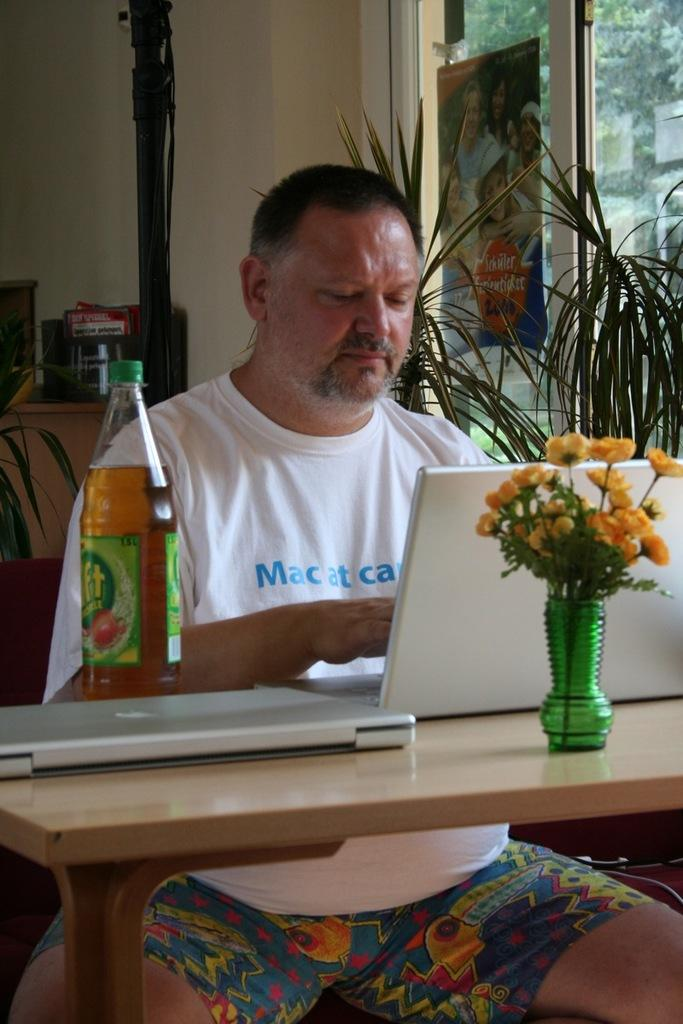Where was the image taken? The image was taken inside a room. What can be seen on the right side of the room? There are plants on the right side of the room. What is in the middle of the room? There is a table in the middle of the room. What objects are on the table? There is a bottle and a laptop on the table. Who is present in the image? There is a person sitting at the table. What types of trucks can be seen in the market in the image? There is no market or trucks present in the image; it is taken inside a room with a table, plants, and a person. 